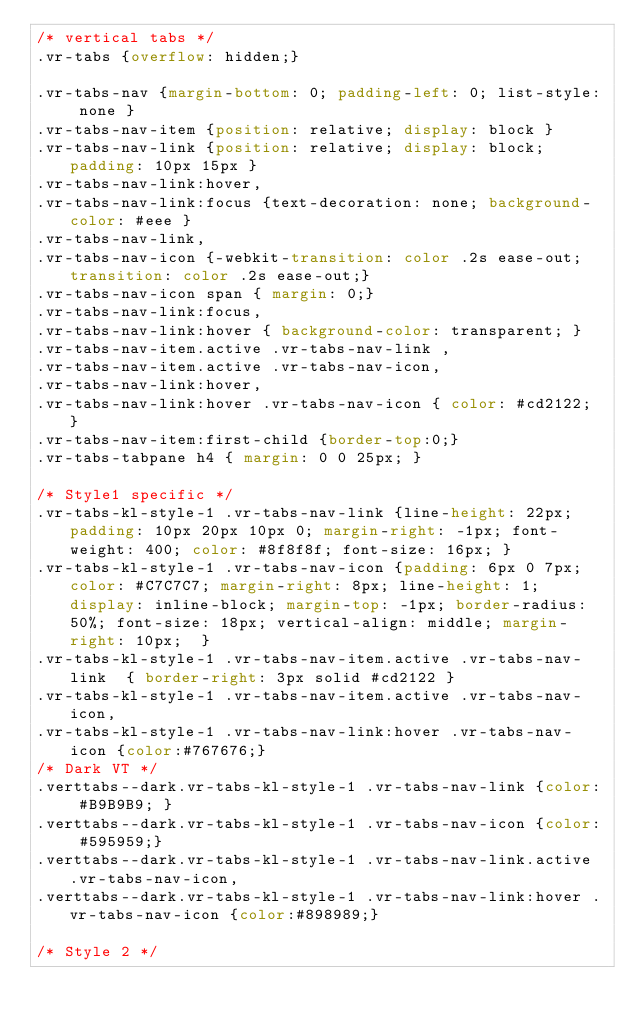Convert code to text. <code><loc_0><loc_0><loc_500><loc_500><_CSS_>/* vertical tabs */
.vr-tabs {overflow: hidden;}

.vr-tabs-nav {margin-bottom: 0; padding-left: 0; list-style: none }
.vr-tabs-nav-item {position: relative; display: block }
.vr-tabs-nav-link {position: relative; display: block; padding: 10px 15px }
.vr-tabs-nav-link:hover,
.vr-tabs-nav-link:focus {text-decoration: none; background-color: #eee }
.vr-tabs-nav-link,
.vr-tabs-nav-icon {-webkit-transition: color .2s ease-out; transition: color .2s ease-out;}
.vr-tabs-nav-icon span { margin: 0;}
.vr-tabs-nav-link:focus,
.vr-tabs-nav-link:hover { background-color: transparent; }
.vr-tabs-nav-item.active .vr-tabs-nav-link ,
.vr-tabs-nav-item.active .vr-tabs-nav-icon,
.vr-tabs-nav-link:hover,
.vr-tabs-nav-link:hover .vr-tabs-nav-icon { color: #cd2122; }
.vr-tabs-nav-item:first-child {border-top:0;}
.vr-tabs-tabpane h4 { margin: 0 0 25px; }

/* Style1 specific */
.vr-tabs-kl-style-1 .vr-tabs-nav-link {line-height: 22px; padding: 10px 20px 10px 0; margin-right: -1px; font-weight: 400; color: #8f8f8f; font-size: 16px; }
.vr-tabs-kl-style-1 .vr-tabs-nav-icon {padding: 6px 0 7px; color: #C7C7C7; margin-right: 8px; line-height: 1; display: inline-block; margin-top: -1px; border-radius: 50%; font-size: 18px; vertical-align: middle; margin-right: 10px;  }
.vr-tabs-kl-style-1 .vr-tabs-nav-item.active .vr-tabs-nav-link  { border-right: 3px solid #cd2122 }
.vr-tabs-kl-style-1 .vr-tabs-nav-item.active .vr-tabs-nav-icon,
.vr-tabs-kl-style-1 .vr-tabs-nav-link:hover .vr-tabs-nav-icon {color:#767676;}
/* Dark VT */
.verttabs--dark.vr-tabs-kl-style-1 .vr-tabs-nav-link {color: #B9B9B9; }
.verttabs--dark.vr-tabs-kl-style-1 .vr-tabs-nav-icon {color: #595959;}
.verttabs--dark.vr-tabs-kl-style-1 .vr-tabs-nav-link.active .vr-tabs-nav-icon,
.verttabs--dark.vr-tabs-kl-style-1 .vr-tabs-nav-link:hover .vr-tabs-nav-icon {color:#898989;}

/* Style 2 */</code> 